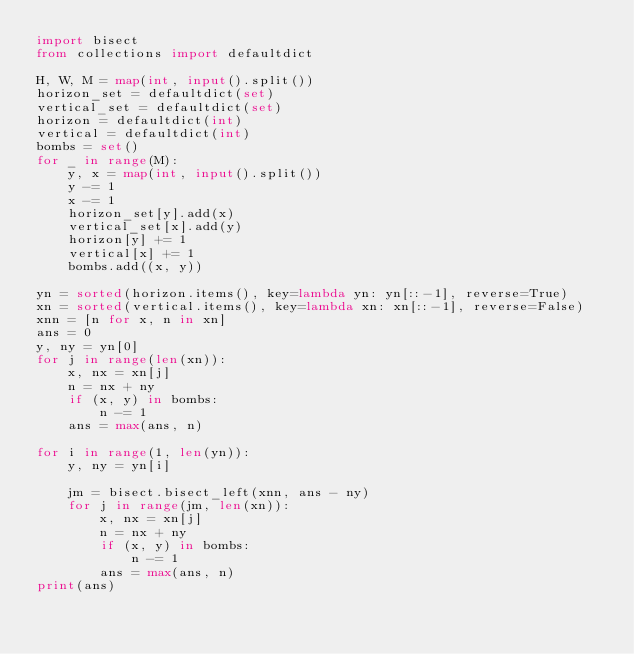Convert code to text. <code><loc_0><loc_0><loc_500><loc_500><_Python_>import bisect
from collections import defaultdict

H, W, M = map(int, input().split())
horizon_set = defaultdict(set)
vertical_set = defaultdict(set)
horizon = defaultdict(int)
vertical = defaultdict(int)
bombs = set()
for _ in range(M):
    y, x = map(int, input().split())
    y -= 1
    x -= 1
    horizon_set[y].add(x)
    vertical_set[x].add(y)
    horizon[y] += 1
    vertical[x] += 1
    bombs.add((x, y))

yn = sorted(horizon.items(), key=lambda yn: yn[::-1], reverse=True)
xn = sorted(vertical.items(), key=lambda xn: xn[::-1], reverse=False)
xnn = [n for x, n in xn]
ans = 0
y, ny = yn[0]
for j in range(len(xn)):
    x, nx = xn[j]
    n = nx + ny
    if (x, y) in bombs:
        n -= 1
    ans = max(ans, n)

for i in range(1, len(yn)):
    y, ny = yn[i]

    jm = bisect.bisect_left(xnn, ans - ny)
    for j in range(jm, len(xn)):
        x, nx = xn[j]
        n = nx + ny
        if (x, y) in bombs:
            n -= 1
        ans = max(ans, n)
print(ans)</code> 